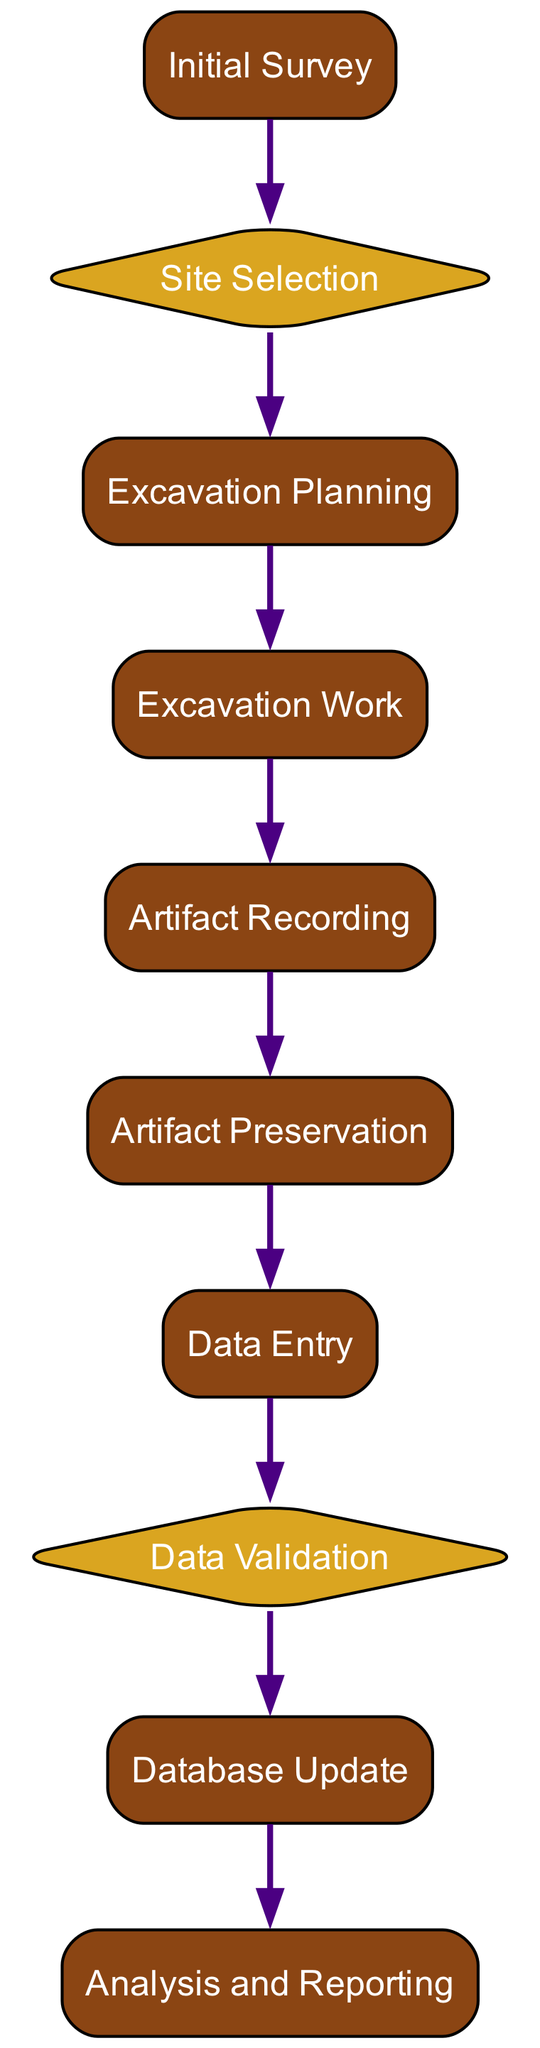What is the first step in the process? The diagram shows "Initial Survey" as the first node, indicating it is the starting point of the process where non-invasive methods are used to identify potential excavation sites.
Answer: Initial Survey How many decision nodes are present in the diagram? By examining the flowchart, there are two decision nodes: "Site Selection" and "Data Validation." These nodes determine the next steps based on certain criteria.
Answer: 2 What comes after "Excavation Planning"? The flow of the diagram indicates that after "Excavation Planning," the next process is "Excavation Work." This is a sequential process that outlines the implementation of the excavation plan.
Answer: Excavation Work What is the last step before the data is analyzed? The last step before analysis is "Database Update," where the validated data gets updated in the archaeological database for further analysis and reporting.
Answer: Database Update Is "Artifact Preservation" a process or a decision? In the diagram, "Artifact Preservation" is categorized as a process node, indicating it involves specific actions to prevent the degradation of artifacts.
Answer: Process What is the relationship between "Artifact Recording" and "Data Entry"? The diagram depicts a direct sequential relationship where "Artifact Recording" leads directly to "Data Entry," indicating that the documentation of artifacts precedes their entry into the database.
Answer: Sequential relationship Which process involves the recording of artifacts? The process that involves recording artifacts is labeled "Artifact Recording," which specifically entails documenting artifacts in situ, including photographs and GPS coordinates.
Answer: Artifact Recording What must occur before "Database Update"? Before "Database Update," the step that must occur is "Data Validation," which ensures that the entered data is accurate and complete by cross-referencing with field notes.
Answer: Data Validation What type of node is "Site Selection"? "Site Selection" is designated as a decision node, which means it requires evaluation of survey data and historical significance to determine whether to proceed with excavation.
Answer: Decision node 